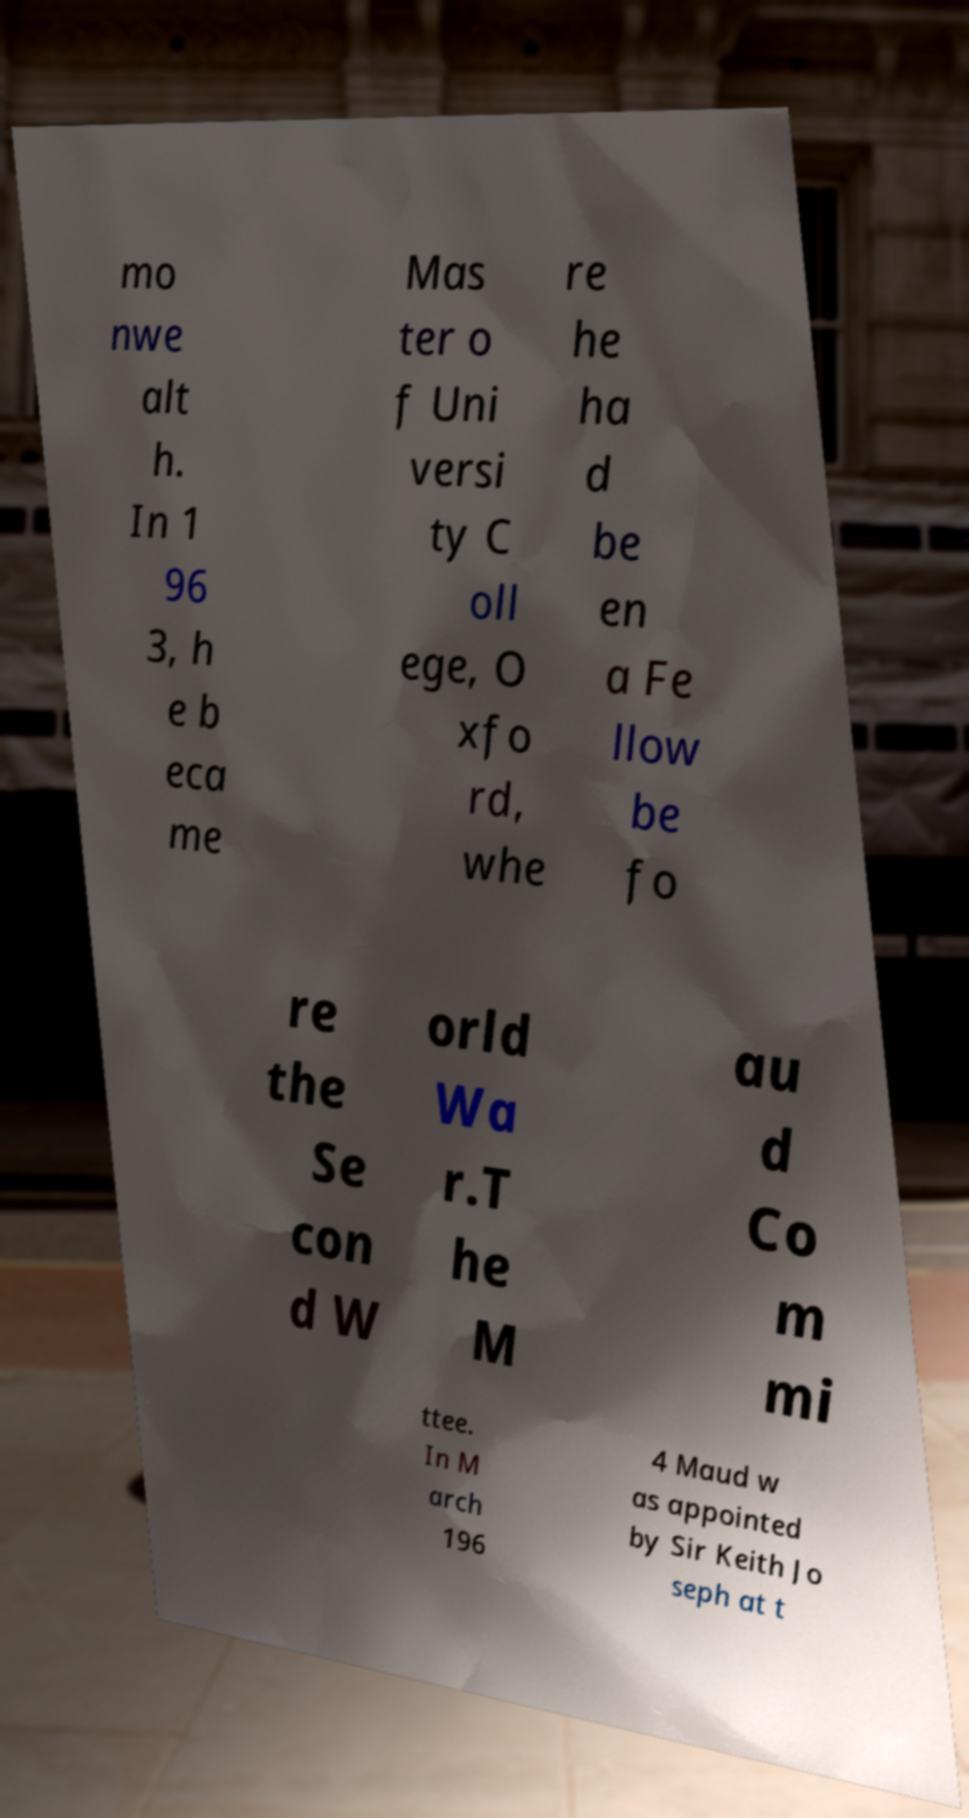Could you extract and type out the text from this image? mo nwe alt h. In 1 96 3, h e b eca me Mas ter o f Uni versi ty C oll ege, O xfo rd, whe re he ha d be en a Fe llow be fo re the Se con d W orld Wa r.T he M au d Co m mi ttee. In M arch 196 4 Maud w as appointed by Sir Keith Jo seph at t 